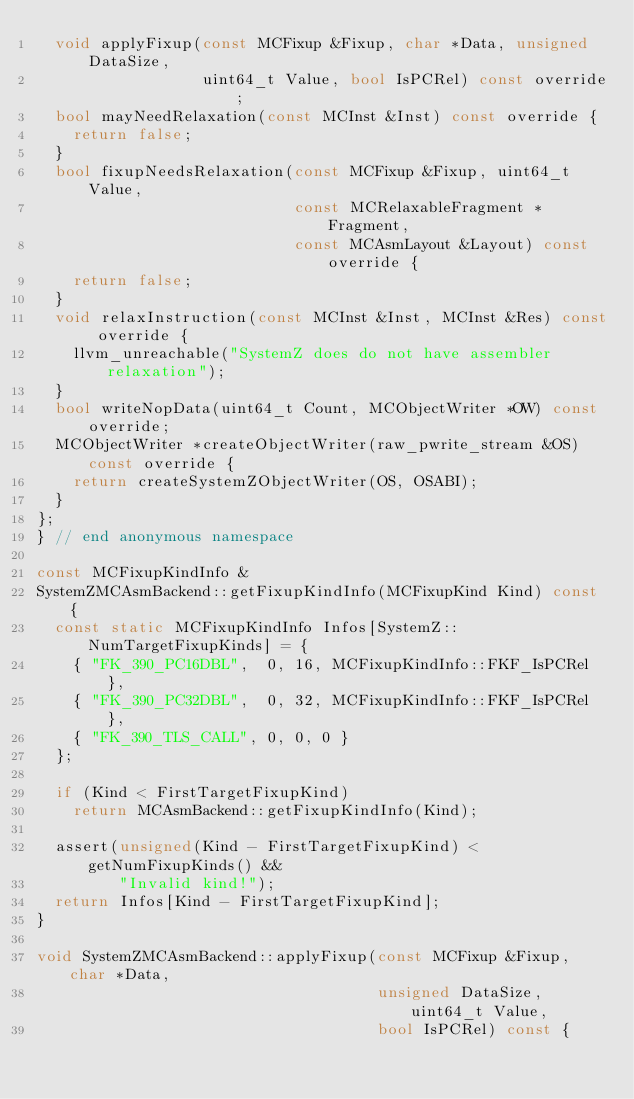<code> <loc_0><loc_0><loc_500><loc_500><_C++_>  void applyFixup(const MCFixup &Fixup, char *Data, unsigned DataSize,
                  uint64_t Value, bool IsPCRel) const override;
  bool mayNeedRelaxation(const MCInst &Inst) const override {
    return false;
  }
  bool fixupNeedsRelaxation(const MCFixup &Fixup, uint64_t Value,
                            const MCRelaxableFragment *Fragment,
                            const MCAsmLayout &Layout) const override {
    return false;
  }
  void relaxInstruction(const MCInst &Inst, MCInst &Res) const override {
    llvm_unreachable("SystemZ does do not have assembler relaxation");
  }
  bool writeNopData(uint64_t Count, MCObjectWriter *OW) const override;
  MCObjectWriter *createObjectWriter(raw_pwrite_stream &OS) const override {
    return createSystemZObjectWriter(OS, OSABI);
  }
};
} // end anonymous namespace

const MCFixupKindInfo &
SystemZMCAsmBackend::getFixupKindInfo(MCFixupKind Kind) const {
  const static MCFixupKindInfo Infos[SystemZ::NumTargetFixupKinds] = {
    { "FK_390_PC16DBL",  0, 16, MCFixupKindInfo::FKF_IsPCRel },
    { "FK_390_PC32DBL",  0, 32, MCFixupKindInfo::FKF_IsPCRel },
    { "FK_390_TLS_CALL", 0, 0, 0 }
  };

  if (Kind < FirstTargetFixupKind)
    return MCAsmBackend::getFixupKindInfo(Kind);

  assert(unsigned(Kind - FirstTargetFixupKind) < getNumFixupKinds() &&
         "Invalid kind!");
  return Infos[Kind - FirstTargetFixupKind];
}

void SystemZMCAsmBackend::applyFixup(const MCFixup &Fixup, char *Data,
                                     unsigned DataSize, uint64_t Value,
                                     bool IsPCRel) const {</code> 